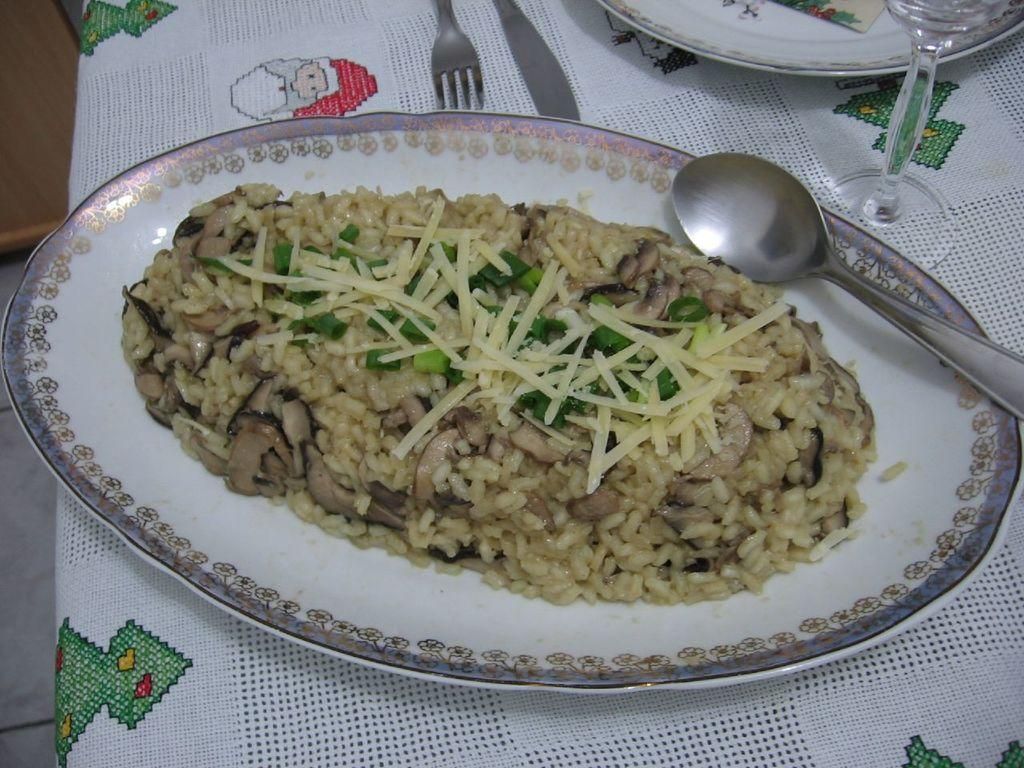What is on the plate that is visible in the image? There is food in a plate in the image. What utensil can be seen in the image? There is a spoon in the image. Are there any other plates visible in the image? Yes, there is another plate in the image. What can be used for drinking in the image? There is a glass in the image. What other utensil is present in the image? There is a fork in the image. What decision is being made by the food in the image? The food in the image is not capable of making decisions, as it is an inanimate object. 